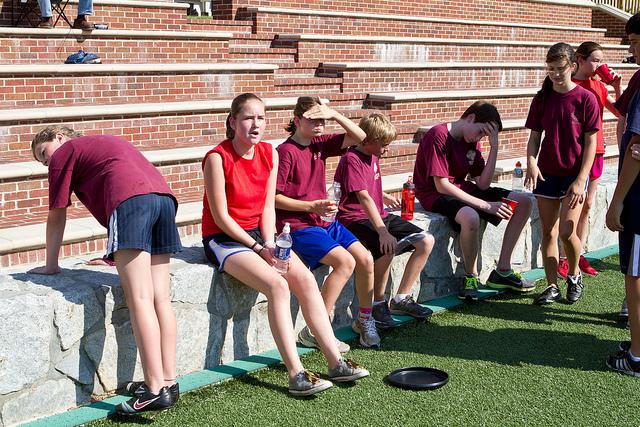How many women are sitting on the cement?
Keep it brief. 2. How many boys are pictured?
Keep it brief. 2. Is there grass in the image?
Answer briefly. Yes. What is the bench made of?
Be succinct. Stone. 